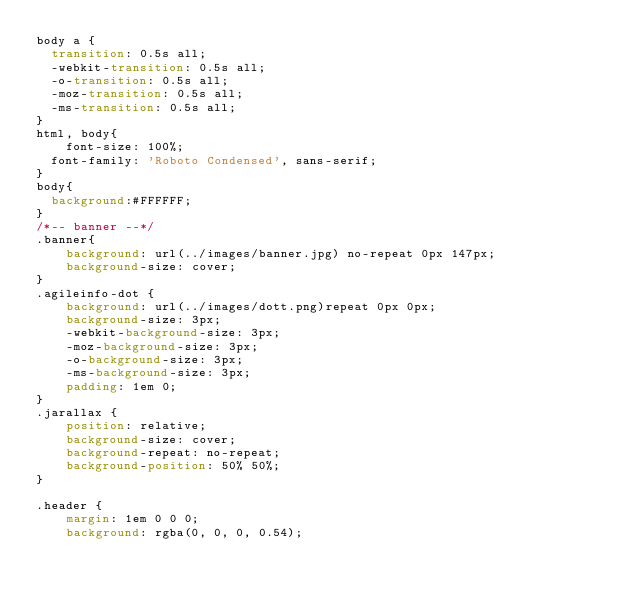Convert code to text. <code><loc_0><loc_0><loc_500><loc_500><_CSS_>body a {
  transition: 0.5s all;
  -webkit-transition: 0.5s all;
  -o-transition: 0.5s all;
  -moz-transition: 0.5s all;
  -ms-transition: 0.5s all;
}
html, body{
    font-size: 100%;
	font-family: 'Roboto Condensed', sans-serif;
}
body{
	background:#FFFFFF;
}
/*-- banner --*/
.banner{
    background: url(../images/banner.jpg) no-repeat 0px 147px;
    background-size: cover;
}
.agileinfo-dot {
    background: url(../images/dott.png)repeat 0px 0px;
    background-size: 3px;
    -webkit-background-size: 3px;
    -moz-background-size: 3px;
    -o-background-size: 3px;
    -ms-background-size: 3px;
    padding: 1em 0;
}
.jarallax {
    position: relative;
    background-size: cover;
    background-repeat: no-repeat;
    background-position: 50% 50%;
}

.header {
    margin: 1em 0 0 0;
    background: rgba(0, 0, 0, 0.54);</code> 